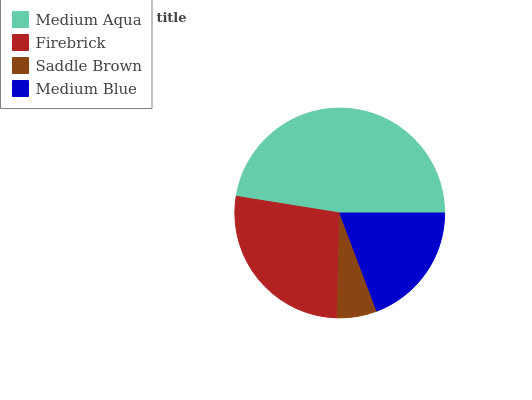Is Saddle Brown the minimum?
Answer yes or no. Yes. Is Medium Aqua the maximum?
Answer yes or no. Yes. Is Firebrick the minimum?
Answer yes or no. No. Is Firebrick the maximum?
Answer yes or no. No. Is Medium Aqua greater than Firebrick?
Answer yes or no. Yes. Is Firebrick less than Medium Aqua?
Answer yes or no. Yes. Is Firebrick greater than Medium Aqua?
Answer yes or no. No. Is Medium Aqua less than Firebrick?
Answer yes or no. No. Is Firebrick the high median?
Answer yes or no. Yes. Is Medium Blue the low median?
Answer yes or no. Yes. Is Medium Blue the high median?
Answer yes or no. No. Is Medium Aqua the low median?
Answer yes or no. No. 